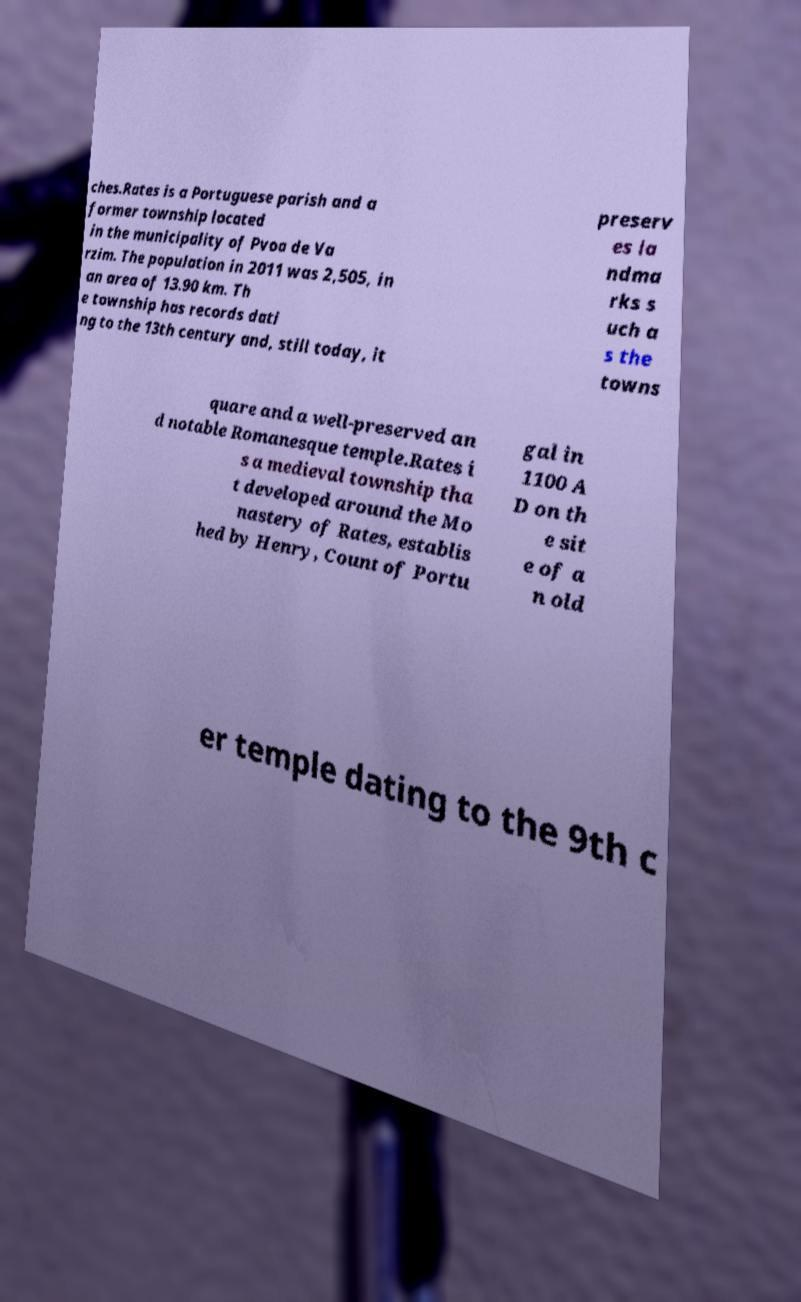There's text embedded in this image that I need extracted. Can you transcribe it verbatim? ches.Rates is a Portuguese parish and a former township located in the municipality of Pvoa de Va rzim. The population in 2011 was 2,505, in an area of 13.90 km. Th e township has records dati ng to the 13th century and, still today, it preserv es la ndma rks s uch a s the towns quare and a well-preserved an d notable Romanesque temple.Rates i s a medieval township tha t developed around the Mo nastery of Rates, establis hed by Henry, Count of Portu gal in 1100 A D on th e sit e of a n old er temple dating to the 9th c 